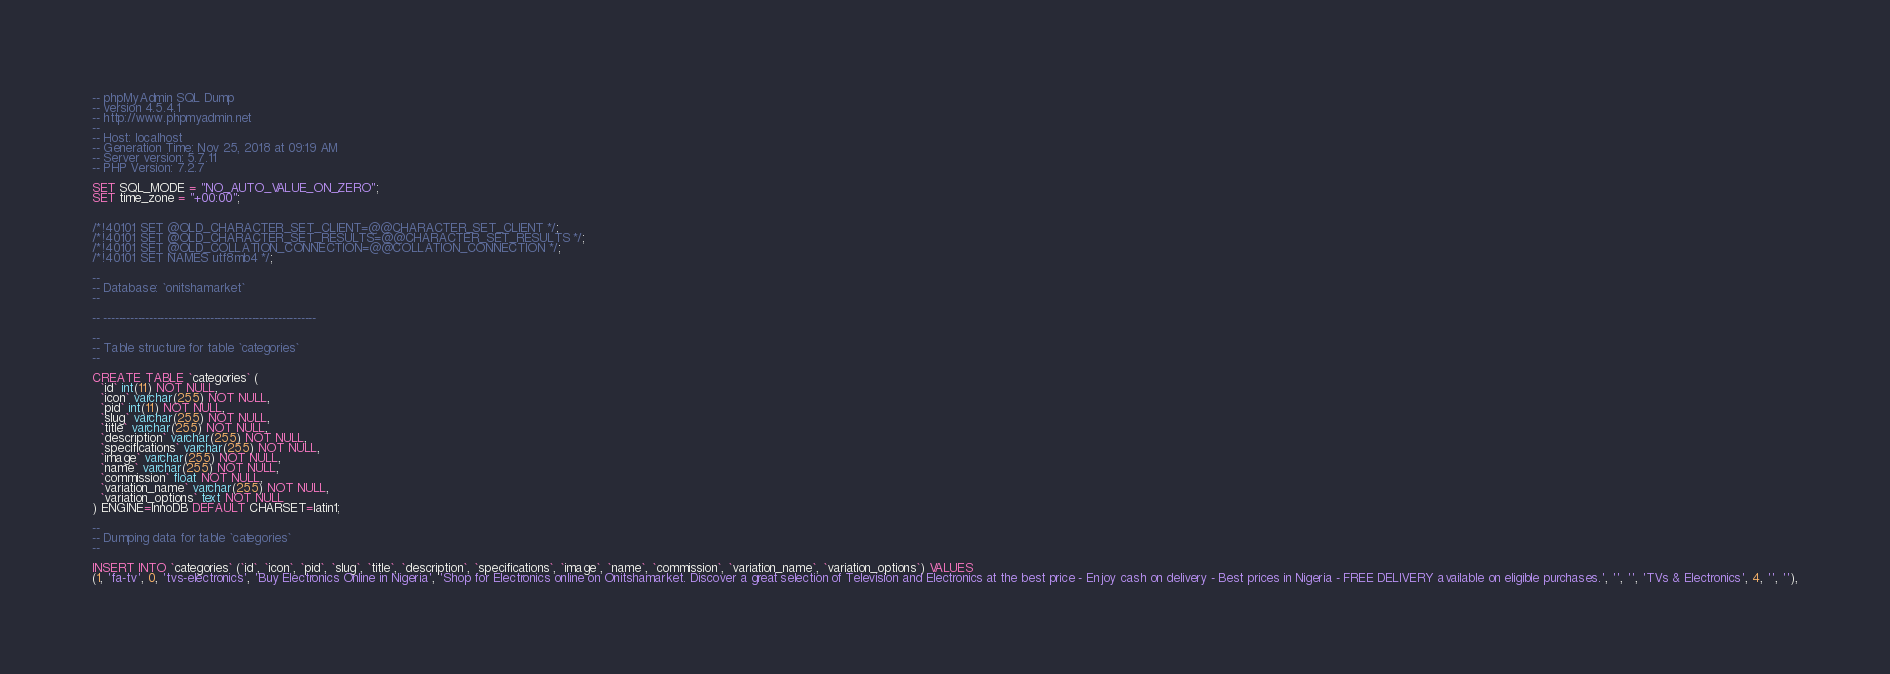<code> <loc_0><loc_0><loc_500><loc_500><_SQL_>-- phpMyAdmin SQL Dump
-- version 4.5.4.1
-- http://www.phpmyadmin.net
--
-- Host: localhost
-- Generation Time: Nov 25, 2018 at 09:19 AM
-- Server version: 5.7.11
-- PHP Version: 7.2.7

SET SQL_MODE = "NO_AUTO_VALUE_ON_ZERO";
SET time_zone = "+00:00";


/*!40101 SET @OLD_CHARACTER_SET_CLIENT=@@CHARACTER_SET_CLIENT */;
/*!40101 SET @OLD_CHARACTER_SET_RESULTS=@@CHARACTER_SET_RESULTS */;
/*!40101 SET @OLD_COLLATION_CONNECTION=@@COLLATION_CONNECTION */;
/*!40101 SET NAMES utf8mb4 */;

--
-- Database: `onitshamarket`
--

-- --------------------------------------------------------

--
-- Table structure for table `categories`
--

CREATE TABLE `categories` (
  `id` int(11) NOT NULL,
  `icon` varchar(255) NOT NULL,
  `pid` int(11) NOT NULL,
  `slug` varchar(255) NOT NULL,
  `title` varchar(255) NOT NULL,
  `description` varchar(255) NOT NULL,
  `specifications` varchar(255) NOT NULL,
  `image` varchar(255) NOT NULL,
  `name` varchar(255) NOT NULL,
  `commission` float NOT NULL,
  `variation_name` varchar(255) NOT NULL,
  `variation_options` text NOT NULL
) ENGINE=InnoDB DEFAULT CHARSET=latin1;

--
-- Dumping data for table `categories`
--

INSERT INTO `categories` (`id`, `icon`, `pid`, `slug`, `title`, `description`, `specifications`, `image`, `name`, `commission`, `variation_name`, `variation_options`) VALUES
(1, 'fa-tv', 0, 'tvs-electronics', 'Buy Electronics Online in Nigeria', 'Shop for Electronics online on Onitshamarket. Discover a great selection of Television and Electronics at the best price - Enjoy cash on delivery - Best prices in Nigeria - FREE DELIVERY available on eligible purchases.', '', '', 'TVs & Electronics', 4, '', ''),</code> 